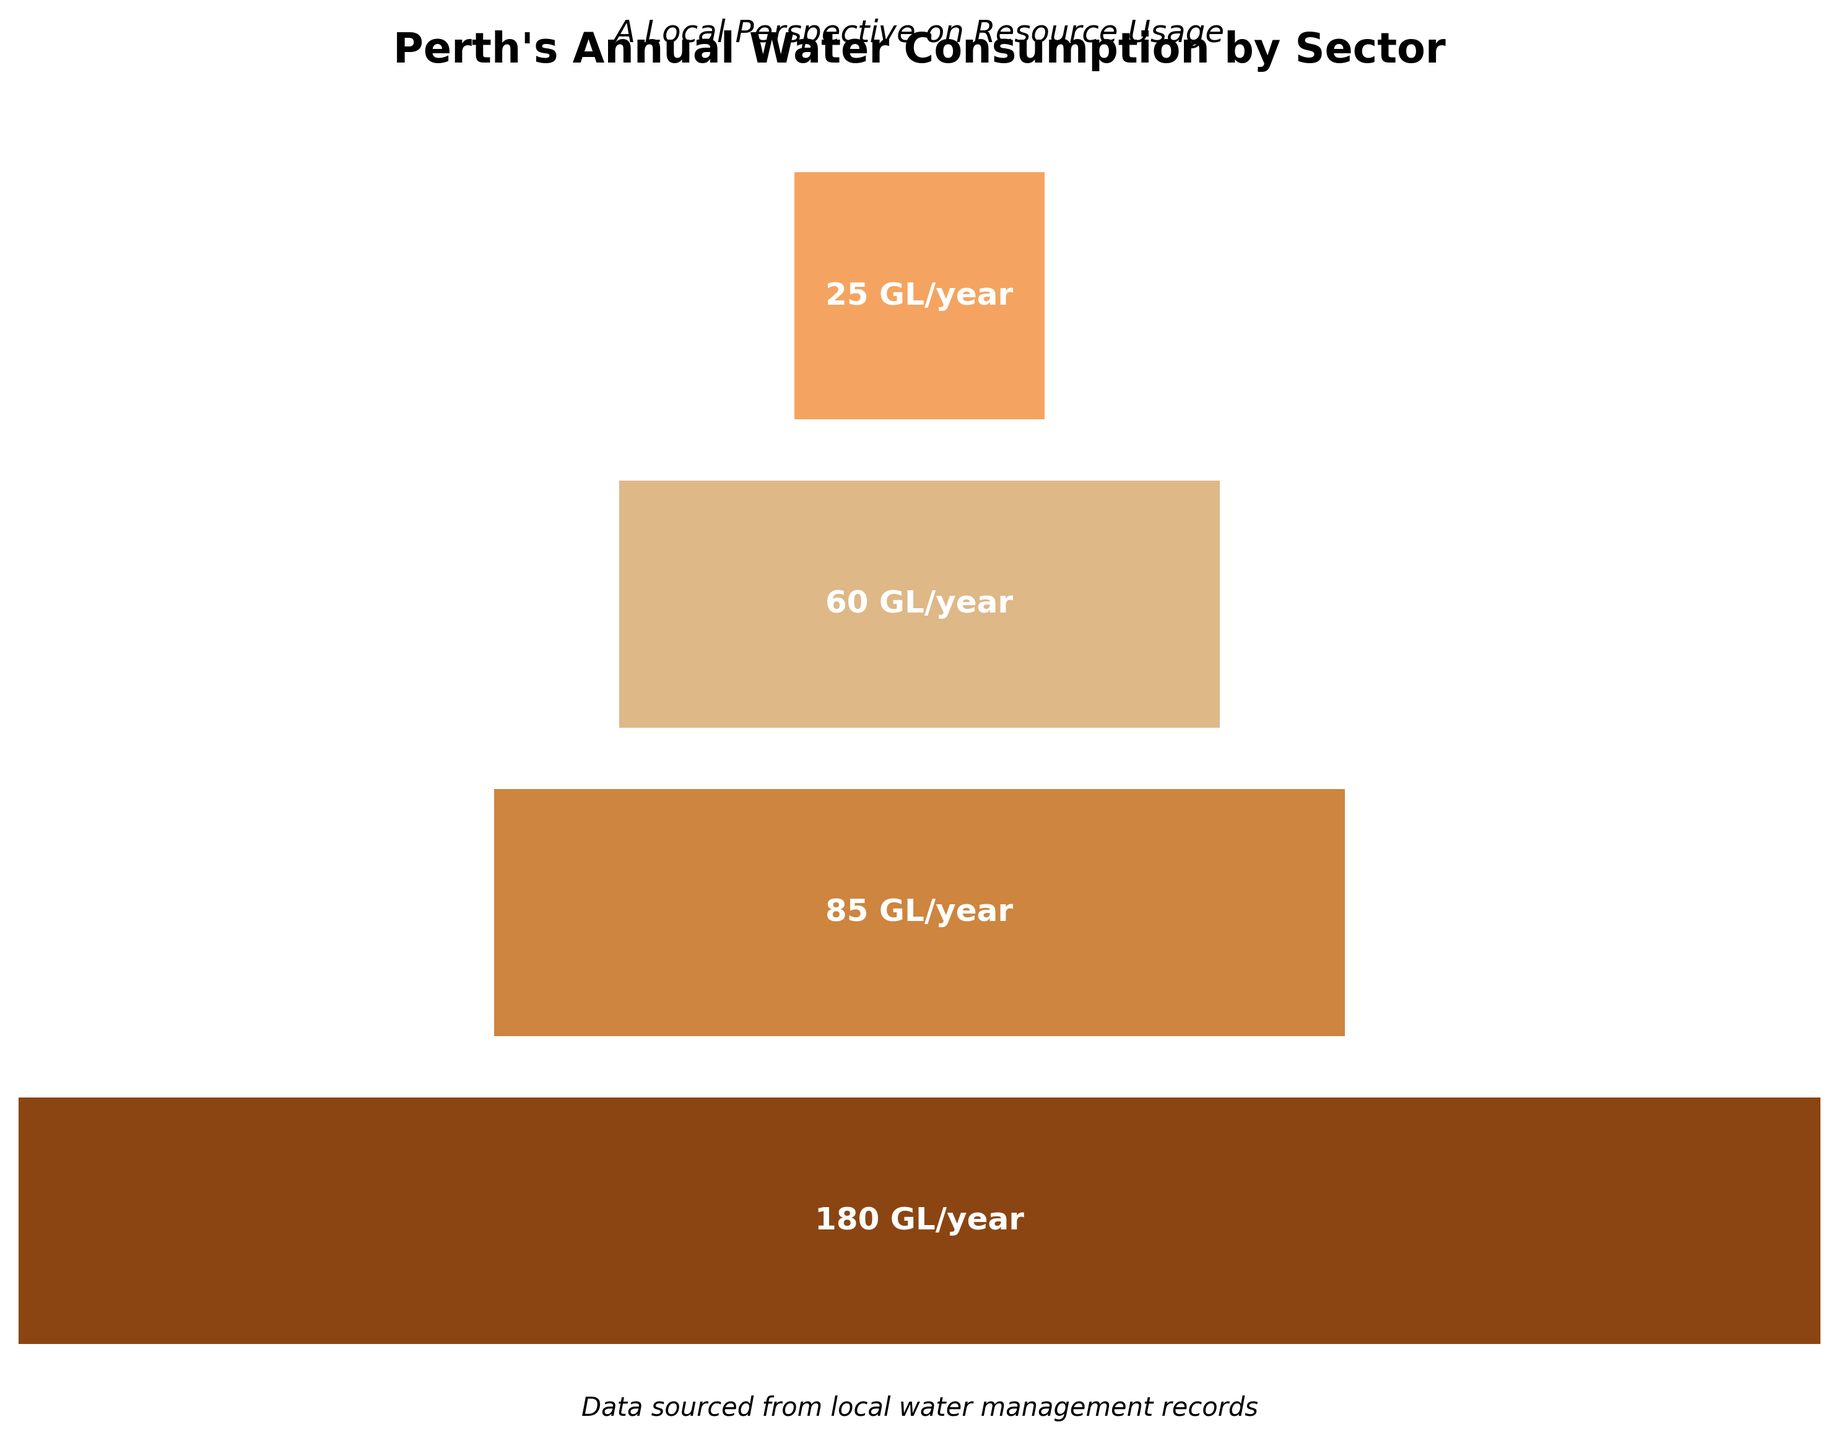What is the total water consumption for all sectors combined? The total water consumption is calculated by summing up the values of all sectors: 180 (Residential) + 85 (Commercial) + 60 (Industrial) + 25 (Public)
Answer: 350 GL/year Which sector accounts for the highest water consumption? By comparing the values, the Residential sector has the highest water consumption of 180 GL/year
Answer: Residential What percentage of the total water consumption is used by the Industrial sector? The Industrial sector uses 60 GL/year. To find the percentage, divide 60 by the total consumption (350) and multiply by 100: (60 / 350) * 100 ≈ 17.14%
Answer: 17.14% By how much does the water consumption of the Commercial sector exceed that of the Public sector? Subtract the Public sector's consumption from the Commercial sector's consumption: 85 - 25 = 60 GL/year
Answer: 60 GL/year Arrange the sectors in ascending order of their water consumption. The sectors in ascending order based on water consumption are: Public (25), Industrial (60), Commercial (85), Residential (180)
Answer: Public, Industrial, Commercial, Residential What is the difference in water consumption between the Residential sector and the combined consumption of the Industrial and Public sectors? First, combine the Industrial and Public sectors: 60 + 25 = 85. Then subtract this value from the Residential sector's consumption: 180 - 85 = 95 GL/year
Answer: 95 GL/year What does the title of the plot indicate? The title indicates that the plot is about Perth's annual water consumption broken down by different sectors
Answer: Perth's Annual Water Consumption by Sector What information does the funnel chart highlight about the distribution of water consumption among different sectors? The funnel chart shows that water consumption is unequal across sectors, with Residential consuming the most and Public consuming the least water
Answer: Unequal distribution of water consumption How much more water does the Residential sector consume compared to the Commercial sector? Subtract the Commercial sector's consumption from the Residential sector's consumption: 180 - 85 = 95 GL/year
Answer: 95 GL/year 